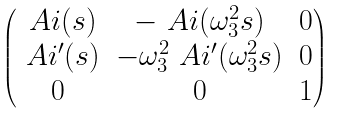<formula> <loc_0><loc_0><loc_500><loc_500>\begin{pmatrix} \ A i ( s ) & - \ A i ( \omega _ { 3 } ^ { 2 } s ) & 0 \\ \ A i ^ { \prime } ( s ) & - \omega _ { 3 } ^ { 2 } \ A i ^ { \prime } ( \omega _ { 3 } ^ { 2 } s ) & 0 \\ 0 & 0 & 1 \end{pmatrix}</formula> 